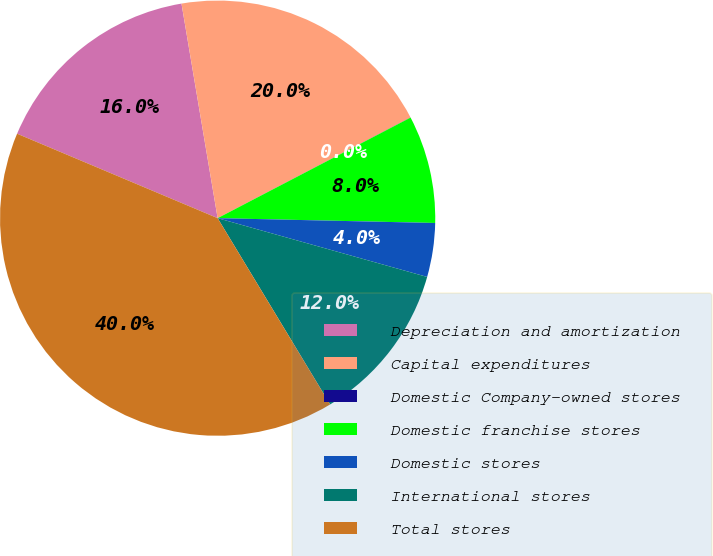Convert chart. <chart><loc_0><loc_0><loc_500><loc_500><pie_chart><fcel>Depreciation and amortization<fcel>Capital expenditures<fcel>Domestic Company-owned stores<fcel>Domestic franchise stores<fcel>Domestic stores<fcel>International stores<fcel>Total stores<nl><fcel>16.0%<fcel>20.0%<fcel>0.01%<fcel>8.0%<fcel>4.0%<fcel>12.0%<fcel>39.99%<nl></chart> 